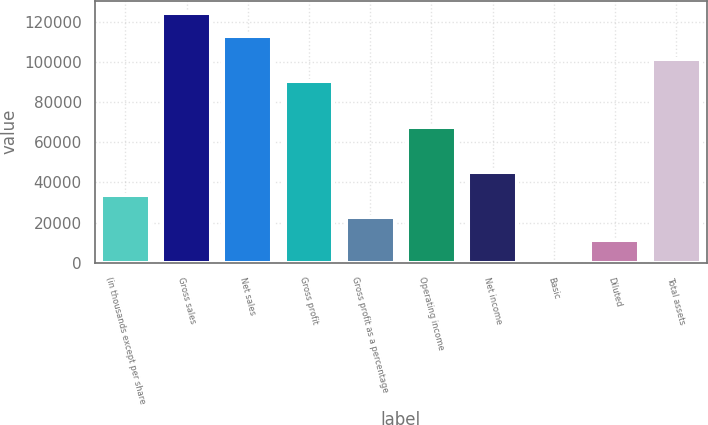Convert chart to OTSL. <chart><loc_0><loc_0><loc_500><loc_500><bar_chart><fcel>(in thousands except per share<fcel>Gross sales<fcel>Net sales<fcel>Gross profit<fcel>Gross profit as a percentage<fcel>Operating income<fcel>Net income<fcel>Basic<fcel>Diluted<fcel>Total assets<nl><fcel>33865.5<fcel>124174<fcel>112885<fcel>90308<fcel>22577<fcel>67731<fcel>45154<fcel>0.04<fcel>11288.5<fcel>101597<nl></chart> 